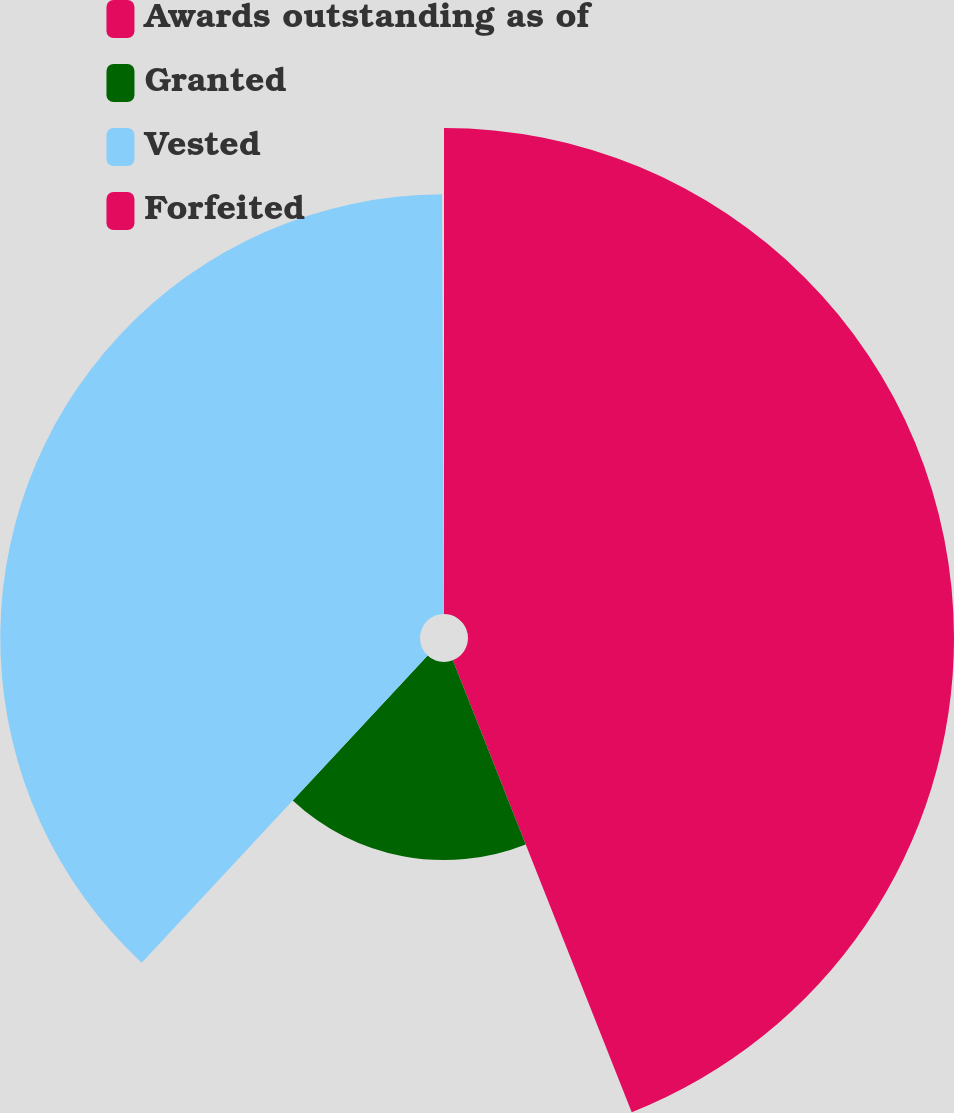<chart> <loc_0><loc_0><loc_500><loc_500><pie_chart><fcel>Awards outstanding as of<fcel>Granted<fcel>Vested<fcel>Forfeited<nl><fcel>44.0%<fcel>17.93%<fcel>38.0%<fcel>0.07%<nl></chart> 